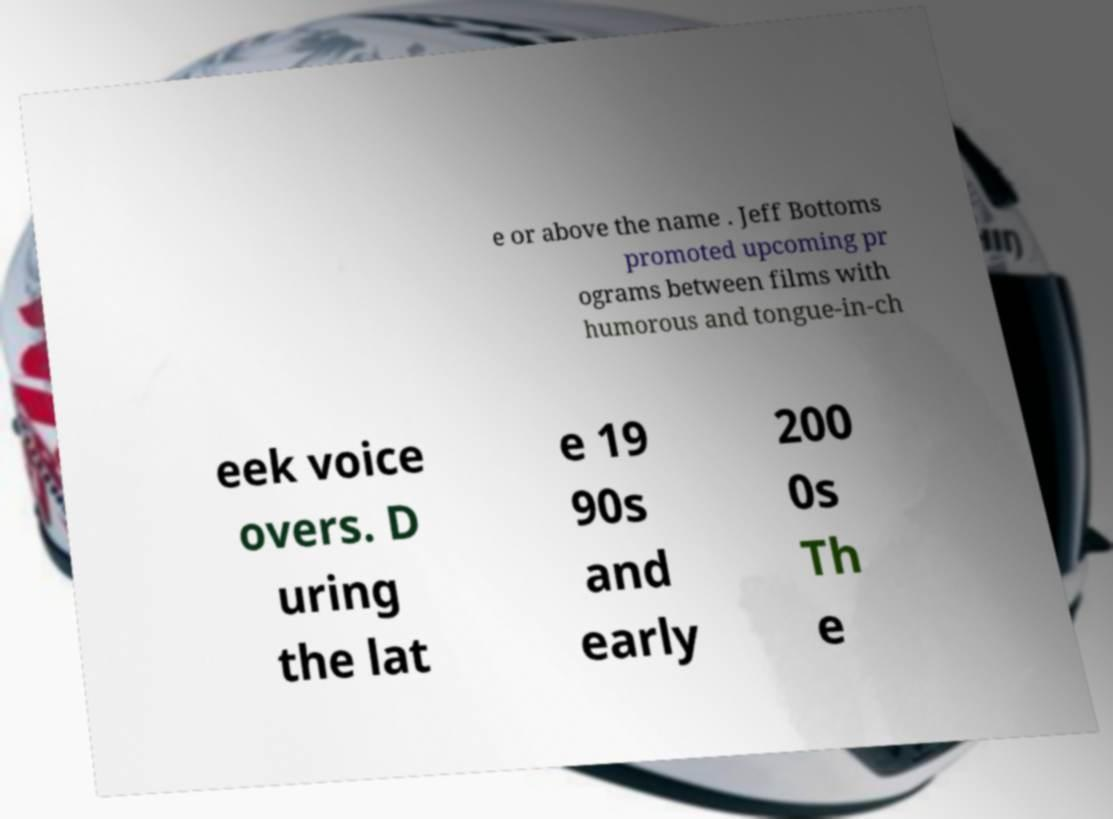For documentation purposes, I need the text within this image transcribed. Could you provide that? e or above the name . Jeff Bottoms promoted upcoming pr ograms between films with humorous and tongue-in-ch eek voice overs. D uring the lat e 19 90s and early 200 0s Th e 